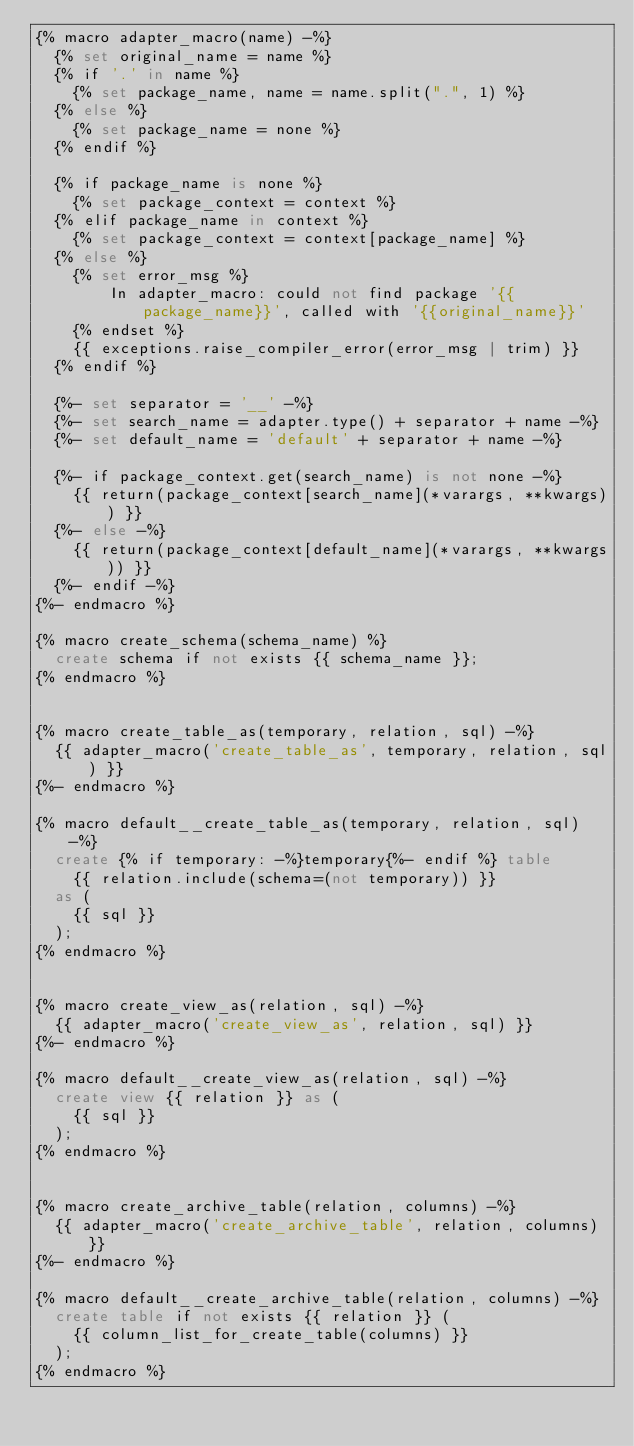Convert code to text. <code><loc_0><loc_0><loc_500><loc_500><_SQL_>{% macro adapter_macro(name) -%}
  {% set original_name = name %}
  {% if '.' in name %}
    {% set package_name, name = name.split(".", 1) %}
  {% else %}
    {% set package_name = none %}
  {% endif %}

  {% if package_name is none %}
    {% set package_context = context %}
  {% elif package_name in context %}
    {% set package_context = context[package_name] %}
  {% else %}
    {% set error_msg %}
        In adapter_macro: could not find package '{{package_name}}', called with '{{original_name}}'
    {% endset %}
    {{ exceptions.raise_compiler_error(error_msg | trim) }}
  {% endif %}

  {%- set separator = '__' -%}
  {%- set search_name = adapter.type() + separator + name -%}
  {%- set default_name = 'default' + separator + name -%}

  {%- if package_context.get(search_name) is not none -%}
    {{ return(package_context[search_name](*varargs, **kwargs)) }}
  {%- else -%}
    {{ return(package_context[default_name](*varargs, **kwargs)) }}
  {%- endif -%}
{%- endmacro %}

{% macro create_schema(schema_name) %}
  create schema if not exists {{ schema_name }};
{% endmacro %}


{% macro create_table_as(temporary, relation, sql) -%}
  {{ adapter_macro('create_table_as', temporary, relation, sql) }}
{%- endmacro %}

{% macro default__create_table_as(temporary, relation, sql) -%}
  create {% if temporary: -%}temporary{%- endif %} table
    {{ relation.include(schema=(not temporary)) }}
  as (
    {{ sql }}
  );
{% endmacro %}


{% macro create_view_as(relation, sql) -%}
  {{ adapter_macro('create_view_as', relation, sql) }}
{%- endmacro %}

{% macro default__create_view_as(relation, sql) -%}
  create view {{ relation }} as (
    {{ sql }}
  );
{% endmacro %}


{% macro create_archive_table(relation, columns) -%}
  {{ adapter_macro('create_archive_table', relation, columns) }}
{%- endmacro %}

{% macro default__create_archive_table(relation, columns) -%}
  create table if not exists {{ relation }} (
    {{ column_list_for_create_table(columns) }}
  );
{% endmacro %}
</code> 